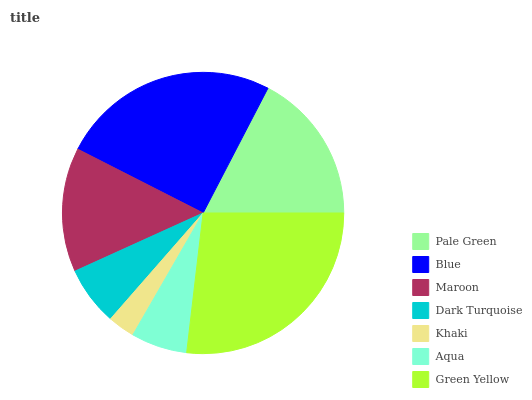Is Khaki the minimum?
Answer yes or no. Yes. Is Green Yellow the maximum?
Answer yes or no. Yes. Is Blue the minimum?
Answer yes or no. No. Is Blue the maximum?
Answer yes or no. No. Is Blue greater than Pale Green?
Answer yes or no. Yes. Is Pale Green less than Blue?
Answer yes or no. Yes. Is Pale Green greater than Blue?
Answer yes or no. No. Is Blue less than Pale Green?
Answer yes or no. No. Is Maroon the high median?
Answer yes or no. Yes. Is Maroon the low median?
Answer yes or no. Yes. Is Pale Green the high median?
Answer yes or no. No. Is Pale Green the low median?
Answer yes or no. No. 